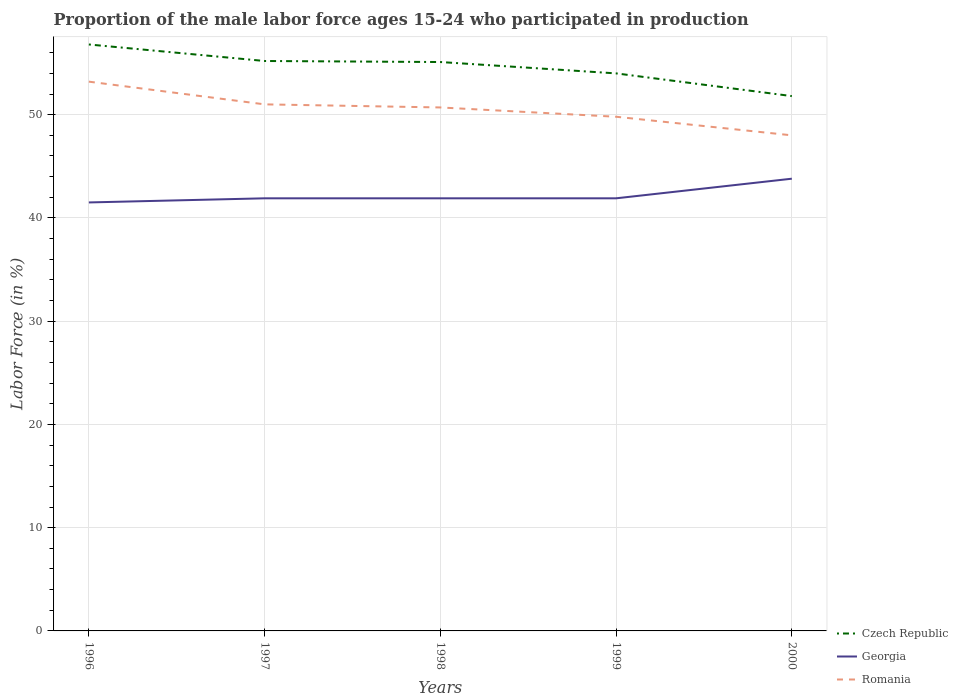Across all years, what is the maximum proportion of the male labor force who participated in production in Georgia?
Provide a succinct answer. 41.5. In which year was the proportion of the male labor force who participated in production in Czech Republic maximum?
Provide a short and direct response. 2000. What is the total proportion of the male labor force who participated in production in Czech Republic in the graph?
Your answer should be very brief. 1.6. What is the difference between the highest and the second highest proportion of the male labor force who participated in production in Georgia?
Give a very brief answer. 2.3. What is the difference between the highest and the lowest proportion of the male labor force who participated in production in Romania?
Keep it short and to the point. 3. How many lines are there?
Offer a very short reply. 3. How many years are there in the graph?
Your answer should be very brief. 5. What is the difference between two consecutive major ticks on the Y-axis?
Your response must be concise. 10. Does the graph contain grids?
Ensure brevity in your answer.  Yes. Where does the legend appear in the graph?
Ensure brevity in your answer.  Bottom right. How are the legend labels stacked?
Provide a succinct answer. Vertical. What is the title of the graph?
Give a very brief answer. Proportion of the male labor force ages 15-24 who participated in production. What is the label or title of the X-axis?
Your response must be concise. Years. What is the label or title of the Y-axis?
Keep it short and to the point. Labor Force (in %). What is the Labor Force (in %) in Czech Republic in 1996?
Your response must be concise. 56.8. What is the Labor Force (in %) in Georgia in 1996?
Offer a terse response. 41.5. What is the Labor Force (in %) of Romania in 1996?
Provide a short and direct response. 53.2. What is the Labor Force (in %) of Czech Republic in 1997?
Keep it short and to the point. 55.2. What is the Labor Force (in %) in Georgia in 1997?
Offer a very short reply. 41.9. What is the Labor Force (in %) in Czech Republic in 1998?
Offer a very short reply. 55.1. What is the Labor Force (in %) in Georgia in 1998?
Offer a terse response. 41.9. What is the Labor Force (in %) in Romania in 1998?
Give a very brief answer. 50.7. What is the Labor Force (in %) in Czech Republic in 1999?
Offer a very short reply. 54. What is the Labor Force (in %) of Georgia in 1999?
Give a very brief answer. 41.9. What is the Labor Force (in %) of Romania in 1999?
Offer a very short reply. 49.8. What is the Labor Force (in %) in Czech Republic in 2000?
Provide a succinct answer. 51.8. What is the Labor Force (in %) in Georgia in 2000?
Provide a succinct answer. 43.8. Across all years, what is the maximum Labor Force (in %) of Czech Republic?
Keep it short and to the point. 56.8. Across all years, what is the maximum Labor Force (in %) in Georgia?
Offer a terse response. 43.8. Across all years, what is the maximum Labor Force (in %) of Romania?
Give a very brief answer. 53.2. Across all years, what is the minimum Labor Force (in %) of Czech Republic?
Your answer should be very brief. 51.8. Across all years, what is the minimum Labor Force (in %) in Georgia?
Keep it short and to the point. 41.5. Across all years, what is the minimum Labor Force (in %) in Romania?
Make the answer very short. 48. What is the total Labor Force (in %) in Czech Republic in the graph?
Give a very brief answer. 272.9. What is the total Labor Force (in %) in Georgia in the graph?
Your answer should be very brief. 211. What is the total Labor Force (in %) of Romania in the graph?
Provide a succinct answer. 252.7. What is the difference between the Labor Force (in %) in Czech Republic in 1996 and that in 1997?
Your answer should be very brief. 1.6. What is the difference between the Labor Force (in %) of Georgia in 1996 and that in 1997?
Provide a succinct answer. -0.4. What is the difference between the Labor Force (in %) of Georgia in 1996 and that in 1998?
Offer a very short reply. -0.4. What is the difference between the Labor Force (in %) in Czech Republic in 1996 and that in 2000?
Make the answer very short. 5. What is the difference between the Labor Force (in %) in Georgia in 1996 and that in 2000?
Provide a short and direct response. -2.3. What is the difference between the Labor Force (in %) of Georgia in 1997 and that in 1998?
Provide a succinct answer. 0. What is the difference between the Labor Force (in %) in Romania in 1997 and that in 2000?
Offer a terse response. 3. What is the difference between the Labor Force (in %) of Romania in 1998 and that in 1999?
Ensure brevity in your answer.  0.9. What is the difference between the Labor Force (in %) in Georgia in 1998 and that in 2000?
Provide a succinct answer. -1.9. What is the difference between the Labor Force (in %) in Georgia in 1999 and that in 2000?
Provide a short and direct response. -1.9. What is the difference between the Labor Force (in %) of Romania in 1999 and that in 2000?
Provide a succinct answer. 1.8. What is the difference between the Labor Force (in %) of Czech Republic in 1996 and the Labor Force (in %) of Romania in 1997?
Your answer should be very brief. 5.8. What is the difference between the Labor Force (in %) in Czech Republic in 1996 and the Labor Force (in %) in Romania in 1998?
Your answer should be very brief. 6.1. What is the difference between the Labor Force (in %) of Georgia in 1996 and the Labor Force (in %) of Romania in 1998?
Provide a short and direct response. -9.2. What is the difference between the Labor Force (in %) of Czech Republic in 1996 and the Labor Force (in %) of Georgia in 1999?
Keep it short and to the point. 14.9. What is the difference between the Labor Force (in %) in Czech Republic in 1997 and the Labor Force (in %) in Georgia in 1998?
Ensure brevity in your answer.  13.3. What is the difference between the Labor Force (in %) of Czech Republic in 1997 and the Labor Force (in %) of Georgia in 1999?
Provide a succinct answer. 13.3. What is the difference between the Labor Force (in %) of Georgia in 1997 and the Labor Force (in %) of Romania in 1999?
Make the answer very short. -7.9. What is the difference between the Labor Force (in %) of Czech Republic in 1997 and the Labor Force (in %) of Georgia in 2000?
Ensure brevity in your answer.  11.4. What is the difference between the Labor Force (in %) in Georgia in 1998 and the Labor Force (in %) in Romania in 1999?
Keep it short and to the point. -7.9. What is the difference between the Labor Force (in %) of Czech Republic in 1998 and the Labor Force (in %) of Romania in 2000?
Keep it short and to the point. 7.1. What is the difference between the Labor Force (in %) of Czech Republic in 1999 and the Labor Force (in %) of Romania in 2000?
Offer a very short reply. 6. What is the difference between the Labor Force (in %) in Georgia in 1999 and the Labor Force (in %) in Romania in 2000?
Offer a very short reply. -6.1. What is the average Labor Force (in %) of Czech Republic per year?
Offer a very short reply. 54.58. What is the average Labor Force (in %) in Georgia per year?
Offer a very short reply. 42.2. What is the average Labor Force (in %) of Romania per year?
Keep it short and to the point. 50.54. In the year 1996, what is the difference between the Labor Force (in %) of Czech Republic and Labor Force (in %) of Georgia?
Offer a very short reply. 15.3. In the year 1996, what is the difference between the Labor Force (in %) in Czech Republic and Labor Force (in %) in Romania?
Your answer should be very brief. 3.6. In the year 1996, what is the difference between the Labor Force (in %) of Georgia and Labor Force (in %) of Romania?
Keep it short and to the point. -11.7. In the year 1997, what is the difference between the Labor Force (in %) of Georgia and Labor Force (in %) of Romania?
Keep it short and to the point. -9.1. In the year 1998, what is the difference between the Labor Force (in %) in Czech Republic and Labor Force (in %) in Romania?
Offer a very short reply. 4.4. In the year 1999, what is the difference between the Labor Force (in %) of Czech Republic and Labor Force (in %) of Georgia?
Your answer should be compact. 12.1. In the year 2000, what is the difference between the Labor Force (in %) in Czech Republic and Labor Force (in %) in Georgia?
Provide a succinct answer. 8. What is the ratio of the Labor Force (in %) in Czech Republic in 1996 to that in 1997?
Your response must be concise. 1.03. What is the ratio of the Labor Force (in %) in Georgia in 1996 to that in 1997?
Give a very brief answer. 0.99. What is the ratio of the Labor Force (in %) in Romania in 1996 to that in 1997?
Provide a short and direct response. 1.04. What is the ratio of the Labor Force (in %) in Czech Republic in 1996 to that in 1998?
Give a very brief answer. 1.03. What is the ratio of the Labor Force (in %) of Romania in 1996 to that in 1998?
Provide a short and direct response. 1.05. What is the ratio of the Labor Force (in %) in Czech Republic in 1996 to that in 1999?
Offer a terse response. 1.05. What is the ratio of the Labor Force (in %) in Romania in 1996 to that in 1999?
Your answer should be compact. 1.07. What is the ratio of the Labor Force (in %) in Czech Republic in 1996 to that in 2000?
Your response must be concise. 1.1. What is the ratio of the Labor Force (in %) of Georgia in 1996 to that in 2000?
Make the answer very short. 0.95. What is the ratio of the Labor Force (in %) of Romania in 1996 to that in 2000?
Your response must be concise. 1.11. What is the ratio of the Labor Force (in %) in Georgia in 1997 to that in 1998?
Give a very brief answer. 1. What is the ratio of the Labor Force (in %) in Romania in 1997 to that in 1998?
Make the answer very short. 1.01. What is the ratio of the Labor Force (in %) in Czech Republic in 1997 to that in 1999?
Provide a succinct answer. 1.02. What is the ratio of the Labor Force (in %) of Georgia in 1997 to that in 1999?
Your answer should be very brief. 1. What is the ratio of the Labor Force (in %) of Romania in 1997 to that in 1999?
Keep it short and to the point. 1.02. What is the ratio of the Labor Force (in %) in Czech Republic in 1997 to that in 2000?
Provide a succinct answer. 1.07. What is the ratio of the Labor Force (in %) of Georgia in 1997 to that in 2000?
Provide a short and direct response. 0.96. What is the ratio of the Labor Force (in %) in Czech Republic in 1998 to that in 1999?
Provide a short and direct response. 1.02. What is the ratio of the Labor Force (in %) of Georgia in 1998 to that in 1999?
Offer a very short reply. 1. What is the ratio of the Labor Force (in %) in Romania in 1998 to that in 1999?
Offer a terse response. 1.02. What is the ratio of the Labor Force (in %) of Czech Republic in 1998 to that in 2000?
Provide a succinct answer. 1.06. What is the ratio of the Labor Force (in %) of Georgia in 1998 to that in 2000?
Provide a succinct answer. 0.96. What is the ratio of the Labor Force (in %) of Romania in 1998 to that in 2000?
Give a very brief answer. 1.06. What is the ratio of the Labor Force (in %) of Czech Republic in 1999 to that in 2000?
Give a very brief answer. 1.04. What is the ratio of the Labor Force (in %) of Georgia in 1999 to that in 2000?
Provide a short and direct response. 0.96. What is the ratio of the Labor Force (in %) in Romania in 1999 to that in 2000?
Your answer should be very brief. 1.04. What is the difference between the highest and the second highest Labor Force (in %) of Czech Republic?
Keep it short and to the point. 1.6. What is the difference between the highest and the second highest Labor Force (in %) of Romania?
Ensure brevity in your answer.  2.2. 